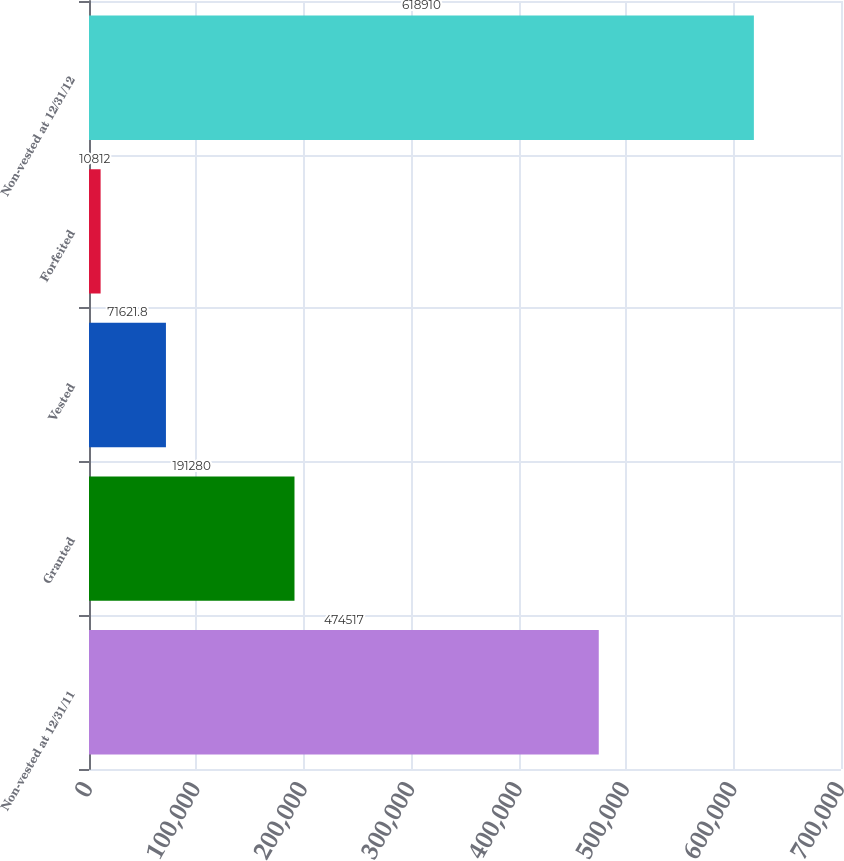Convert chart. <chart><loc_0><loc_0><loc_500><loc_500><bar_chart><fcel>Non-vested at 12/31/11<fcel>Granted<fcel>Vested<fcel>Forfeited<fcel>Non-vested at 12/31/12<nl><fcel>474517<fcel>191280<fcel>71621.8<fcel>10812<fcel>618910<nl></chart> 